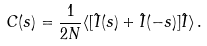Convert formula to latex. <formula><loc_0><loc_0><loc_500><loc_500>C ( s ) = \frac { 1 } { 2 N } \langle [ \hat { I } ( s ) + \hat { I } ( - s ) ] \hat { I } \rangle \, .</formula> 